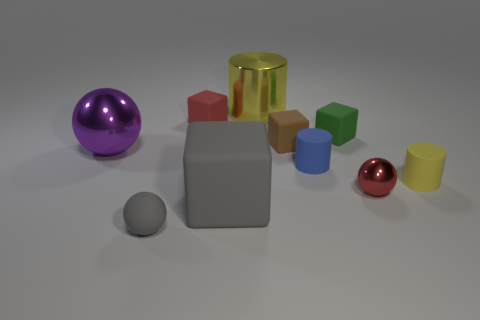Subtract all yellow cylinders. How many cylinders are left? 1 Subtract all red cubes. How many cubes are left? 3 Subtract all cubes. How many objects are left? 6 Subtract 1 spheres. How many spheres are left? 2 Subtract all brown blocks. Subtract all brown spheres. How many blocks are left? 3 Subtract all green cylinders. How many red cubes are left? 1 Subtract all tiny green blocks. Subtract all metallic spheres. How many objects are left? 7 Add 5 metal objects. How many metal objects are left? 8 Add 9 small green blocks. How many small green blocks exist? 10 Subtract 0 cyan blocks. How many objects are left? 10 